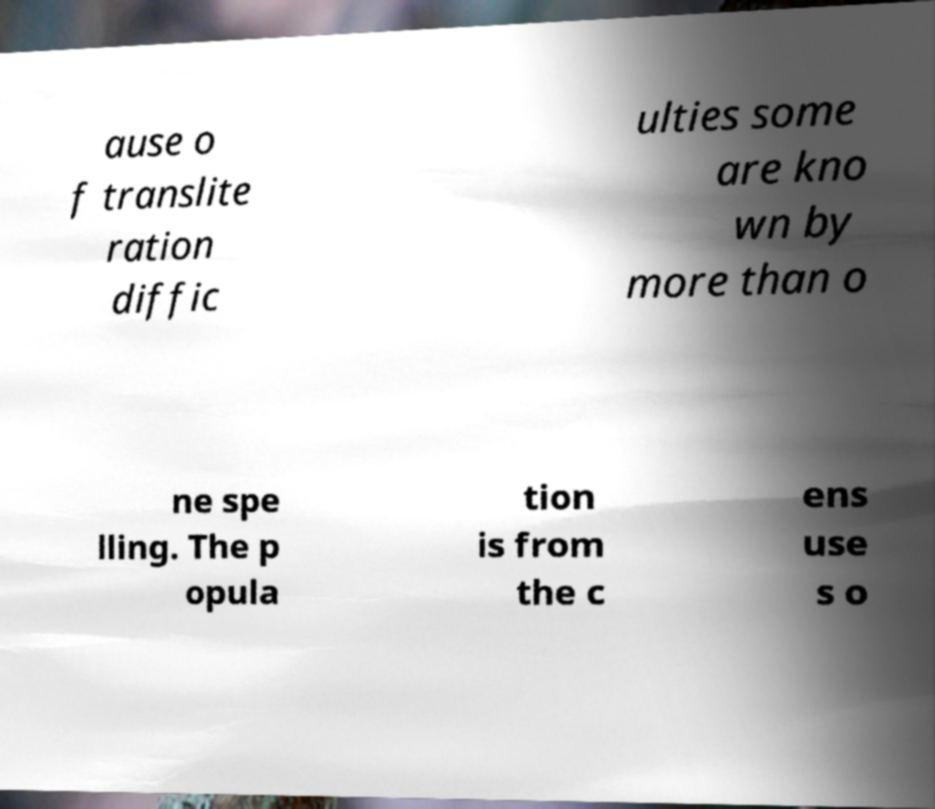Could you extract and type out the text from this image? ause o f translite ration diffic ulties some are kno wn by more than o ne spe lling. The p opula tion is from the c ens use s o 